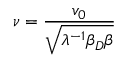Convert formula to latex. <formula><loc_0><loc_0><loc_500><loc_500>\nu = \frac { v _ { 0 } } { \sqrt { \lambda ^ { - 1 } \beta _ { D } \beta } }</formula> 